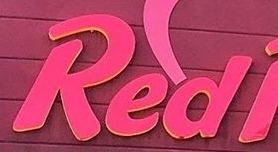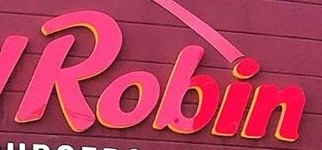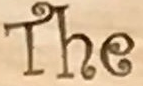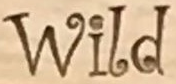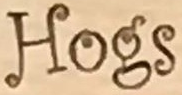Identify the words shown in these images in order, separated by a semicolon. Red; Robin; The; Wild; Hogs 